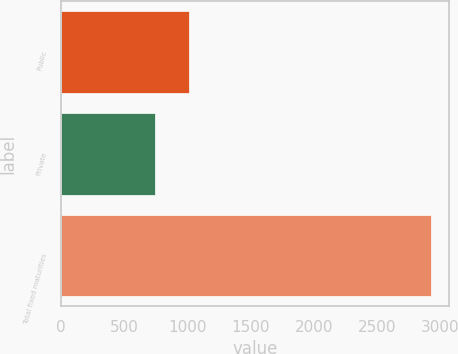Convert chart to OTSL. <chart><loc_0><loc_0><loc_500><loc_500><bar_chart><fcel>Public<fcel>Private<fcel>Total fixed maturities<nl><fcel>1015<fcel>743.2<fcel>2928.9<nl></chart> 